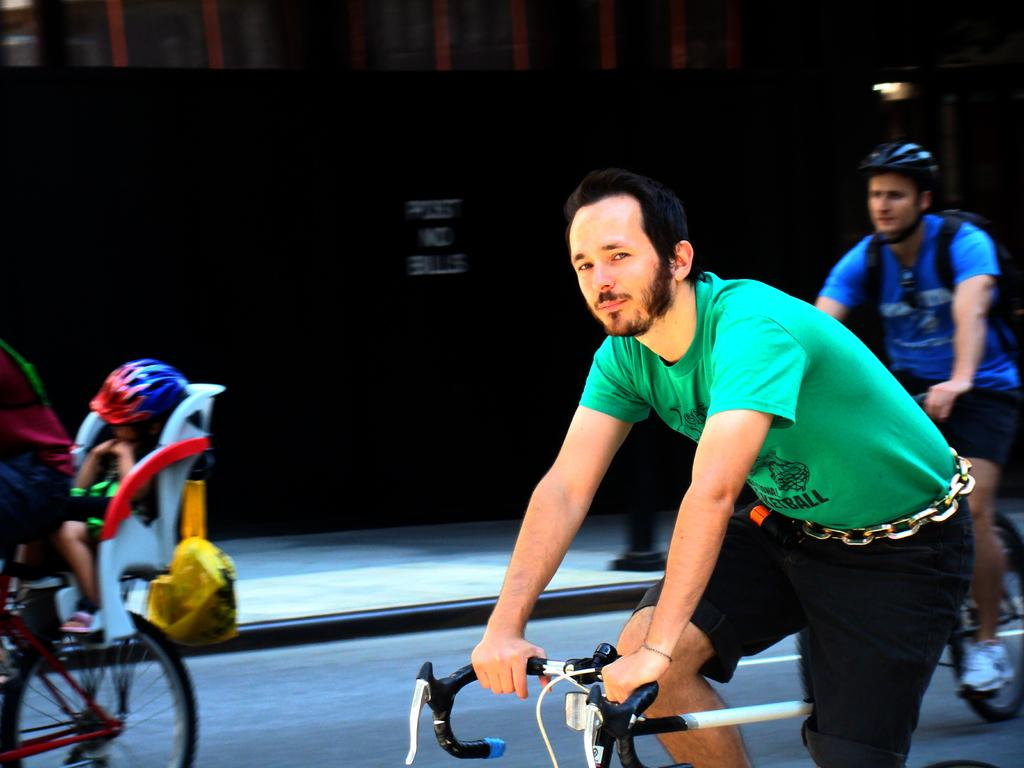What is happening in the image? There is a cycling race in the image. How many persons are participating in the race? There are three persons riding cycles in the race. What can be seen in the background of the image? There is a black color board in the background of the image. What type of hot trade is being conducted by the cyclists in the image? There is no mention of any trade or hot trade in the image; it features a cycling race with three participants. 